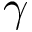<formula> <loc_0><loc_0><loc_500><loc_500>\gamma</formula> 